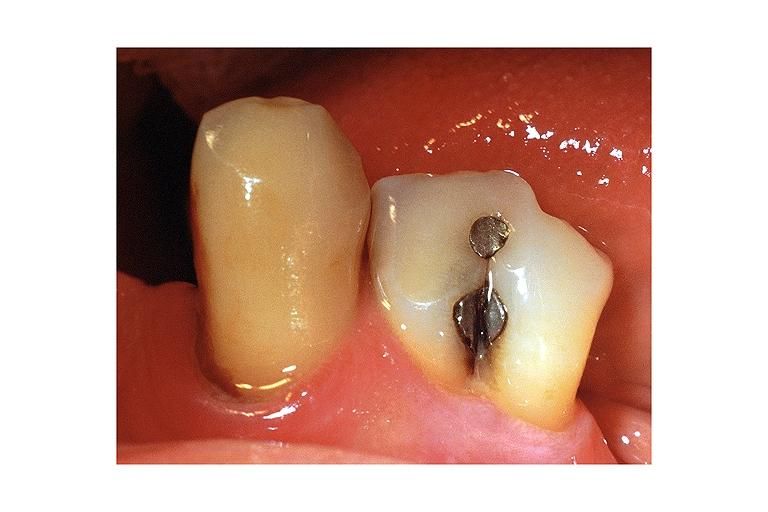where is this?
Answer the question using a single word or phrase. Oral 